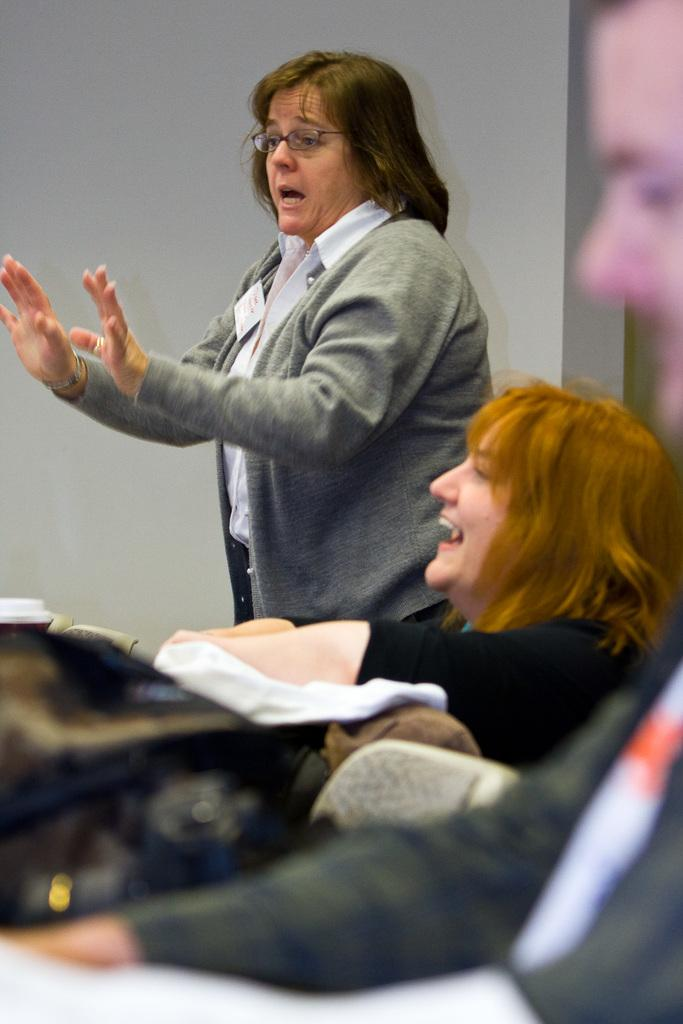How many people are present in the image? There are two people in the image, a man and a woman. What are the man and woman doing in the image? Both the man and woman are sitting on chairs. Can you describe the background of the image? There is a woman standing in the background of the image, and there is a wall in the background as well. What type of boats can be seen in the image? There are no boats present in the image. How does the man's feeling about the woman in the image manifest itself physically? The image does not provide information about the man's feelings or any physical manifestation of those feelings. 